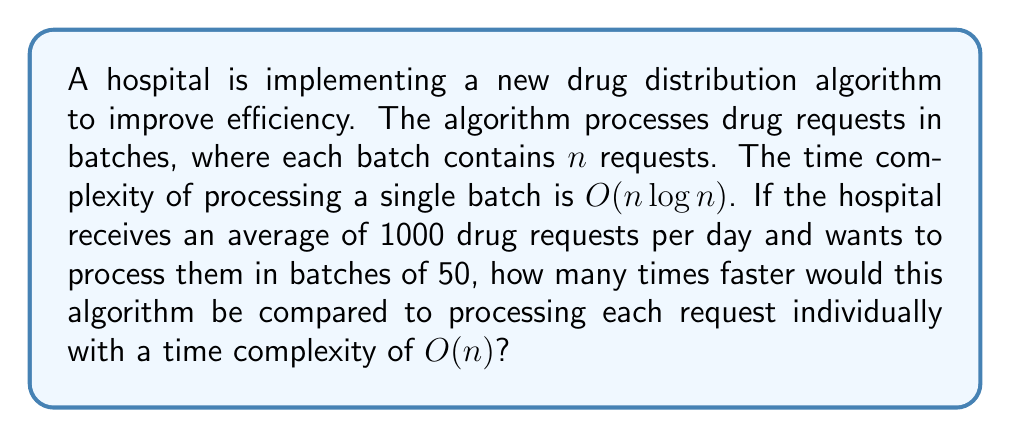What is the answer to this math problem? To solve this problem, we need to compare the time complexities of the two approaches:

1. New algorithm (batch processing):
   - Number of requests per day: 1000
   - Batch size: 50
   - Number of batches: $1000 / 50 = 20$
   - Time complexity for each batch: $O(50 \log 50)$
   - Total time complexity: $20 \times O(50 \log 50) = O(1000 \log 50)$

2. Individual processing:
   - Number of requests per day: 1000
   - Time complexity: $O(1000)$

To compare the efficiency, we need to calculate the ratio of the time complexities:

$$\text{Efficiency ratio} = \frac{O(1000)}{O(1000 \log 50)}$$

Simplifying:
$$\text{Efficiency ratio} = \frac{1000}{1000 \log 50} = \frac{1}{\log 50}$$

To calculate $\log 50$, we can use the change of base formula:
$$\log 50 = \frac{\ln 50}{\ln 2} \approx 5.64$$

Therefore, the efficiency ratio is:
$$\text{Efficiency ratio} = \frac{1}{\log 50} \approx \frac{1}{5.64} \approx 0.177$$

This means that the new algorithm is approximately $\frac{1}{0.177} \approx 5.65$ times faster than processing each request individually.
Answer: The new drug distribution algorithm is approximately 5.65 times faster than processing each request individually. 